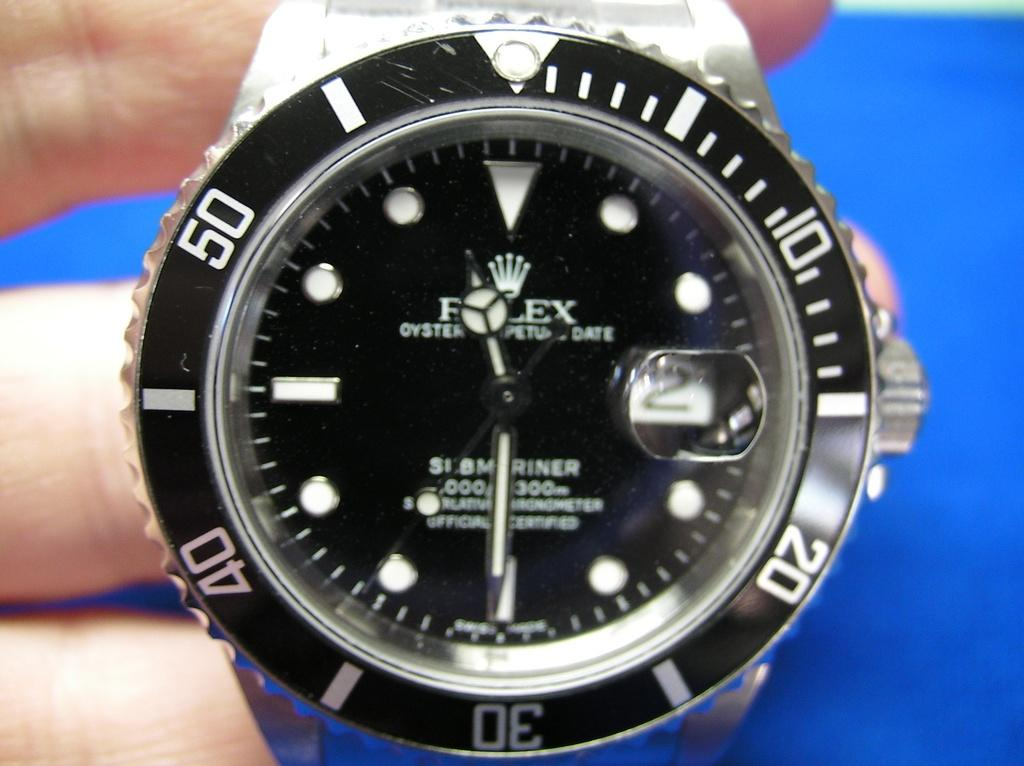<image>
Relay a brief, clear account of the picture shown. A rolex watch on a blue bakground with numbers around the edge. 